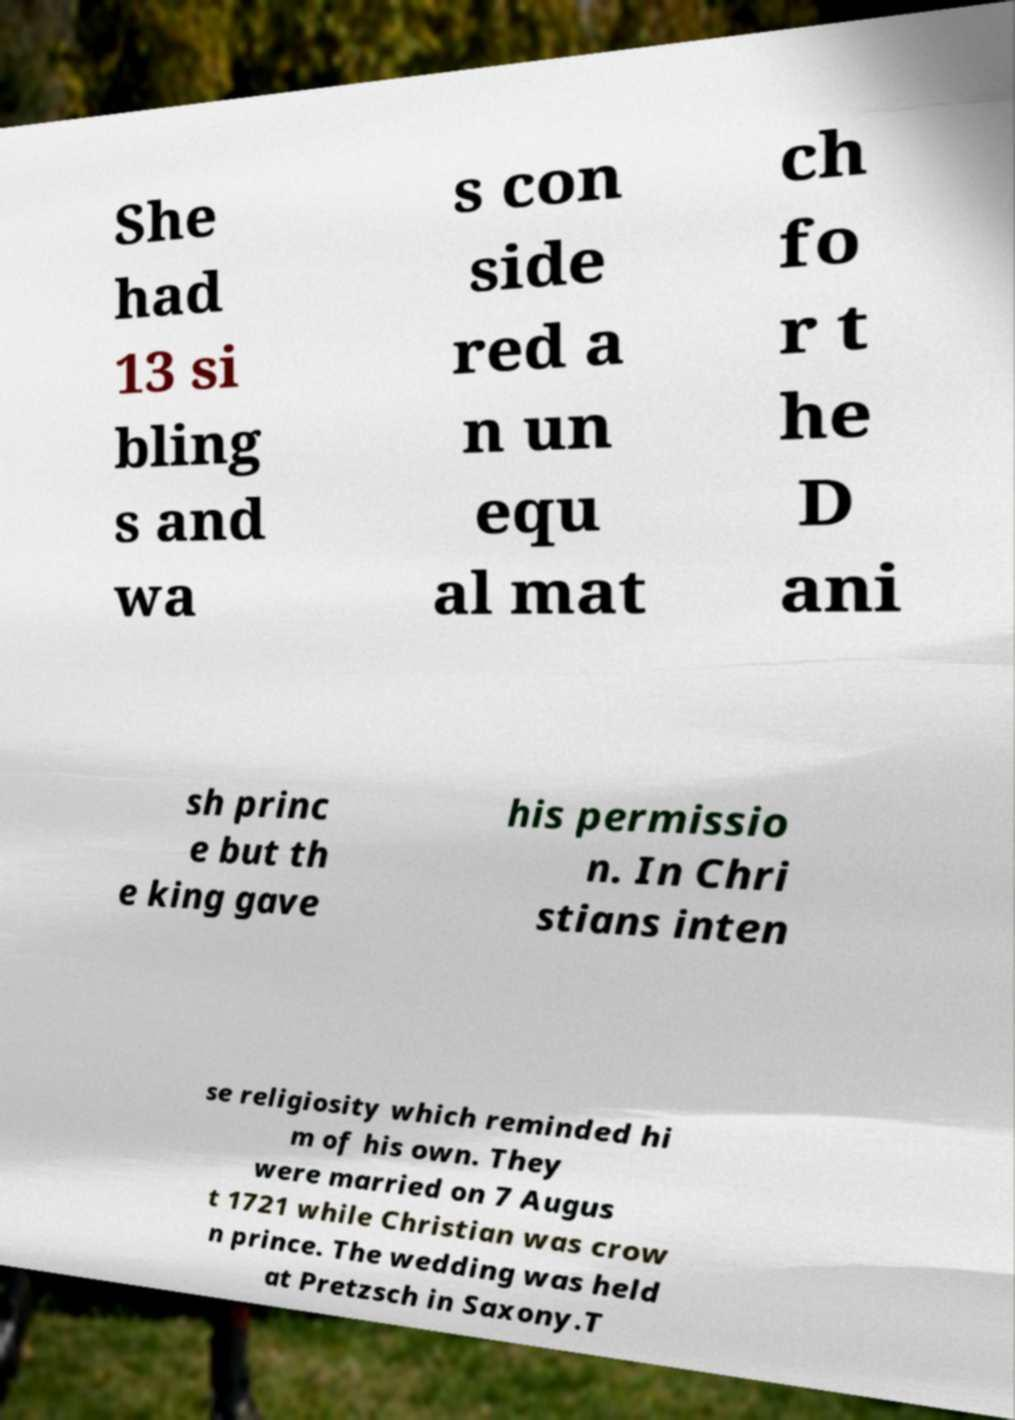Can you accurately transcribe the text from the provided image for me? She had 13 si bling s and wa s con side red a n un equ al mat ch fo r t he D ani sh princ e but th e king gave his permissio n. In Chri stians inten se religiosity which reminded hi m of his own. They were married on 7 Augus t 1721 while Christian was crow n prince. The wedding was held at Pretzsch in Saxony.T 